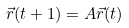Convert formula to latex. <formula><loc_0><loc_0><loc_500><loc_500>\vec { r } ( t + 1 ) = A \vec { r } ( t )</formula> 